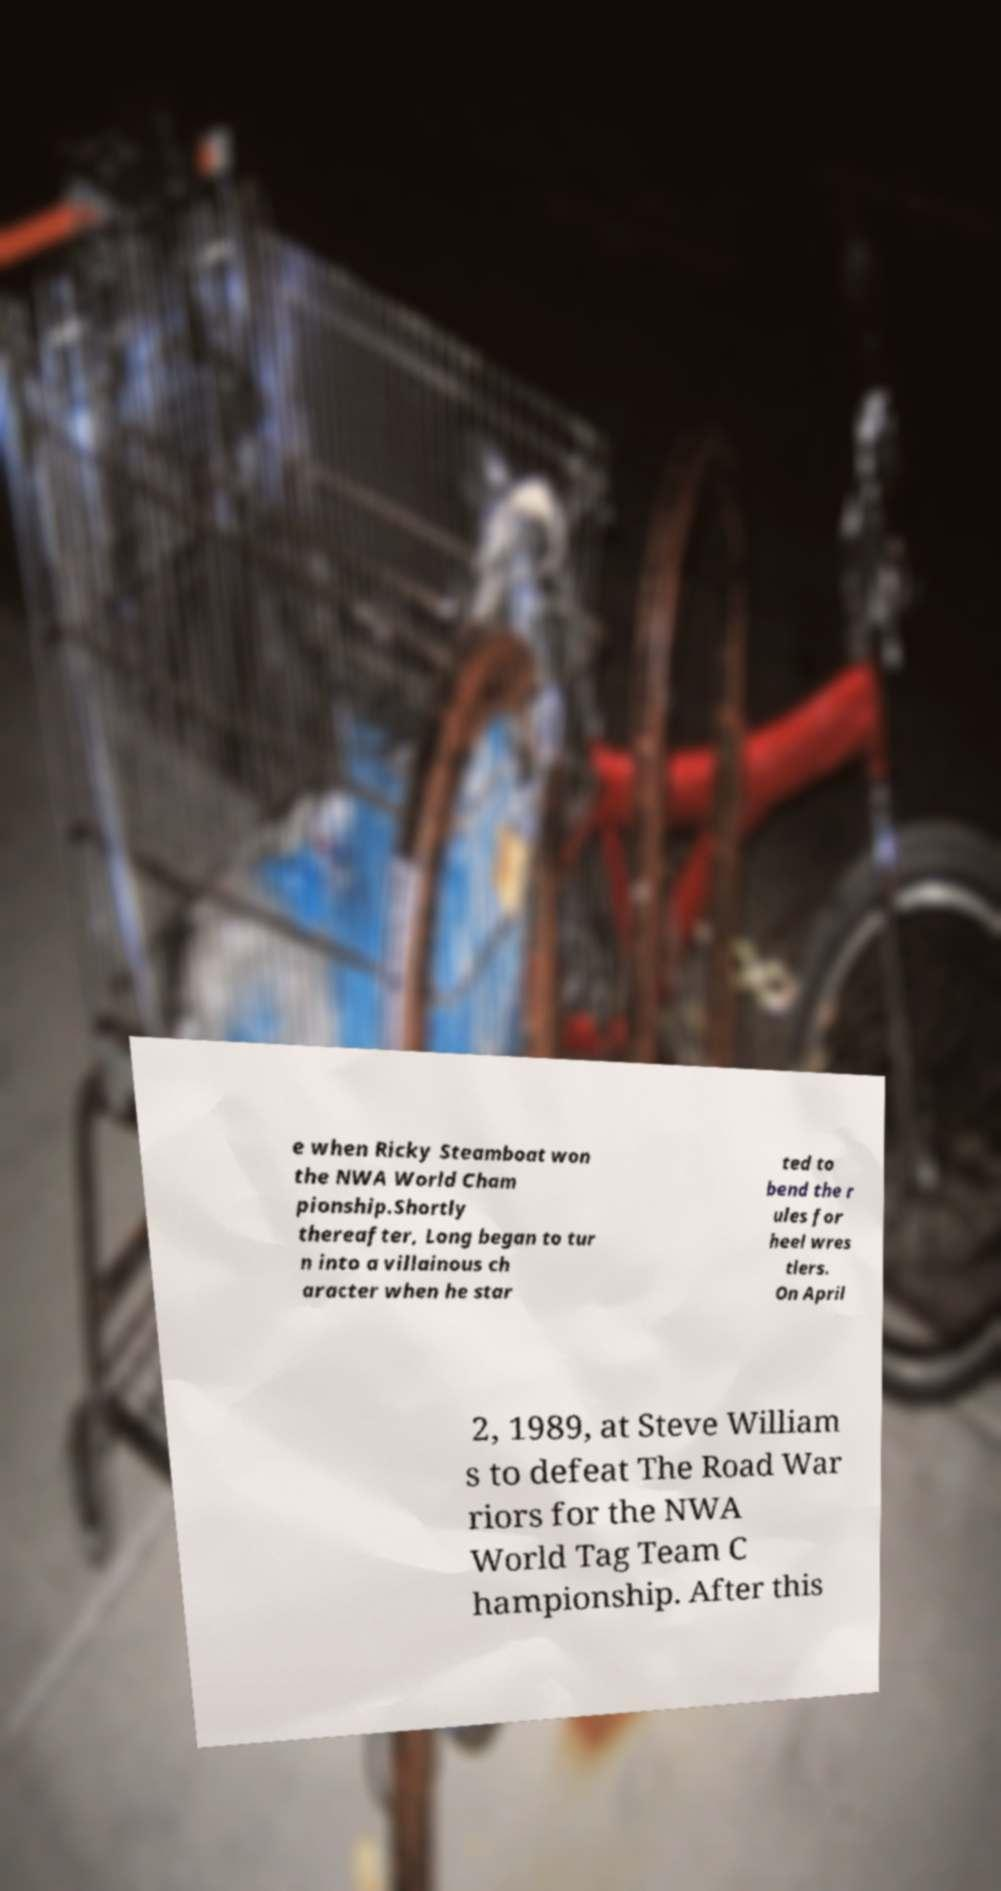For documentation purposes, I need the text within this image transcribed. Could you provide that? e when Ricky Steamboat won the NWA World Cham pionship.Shortly thereafter, Long began to tur n into a villainous ch aracter when he star ted to bend the r ules for heel wres tlers. On April 2, 1989, at Steve William s to defeat The Road War riors for the NWA World Tag Team C hampionship. After this 